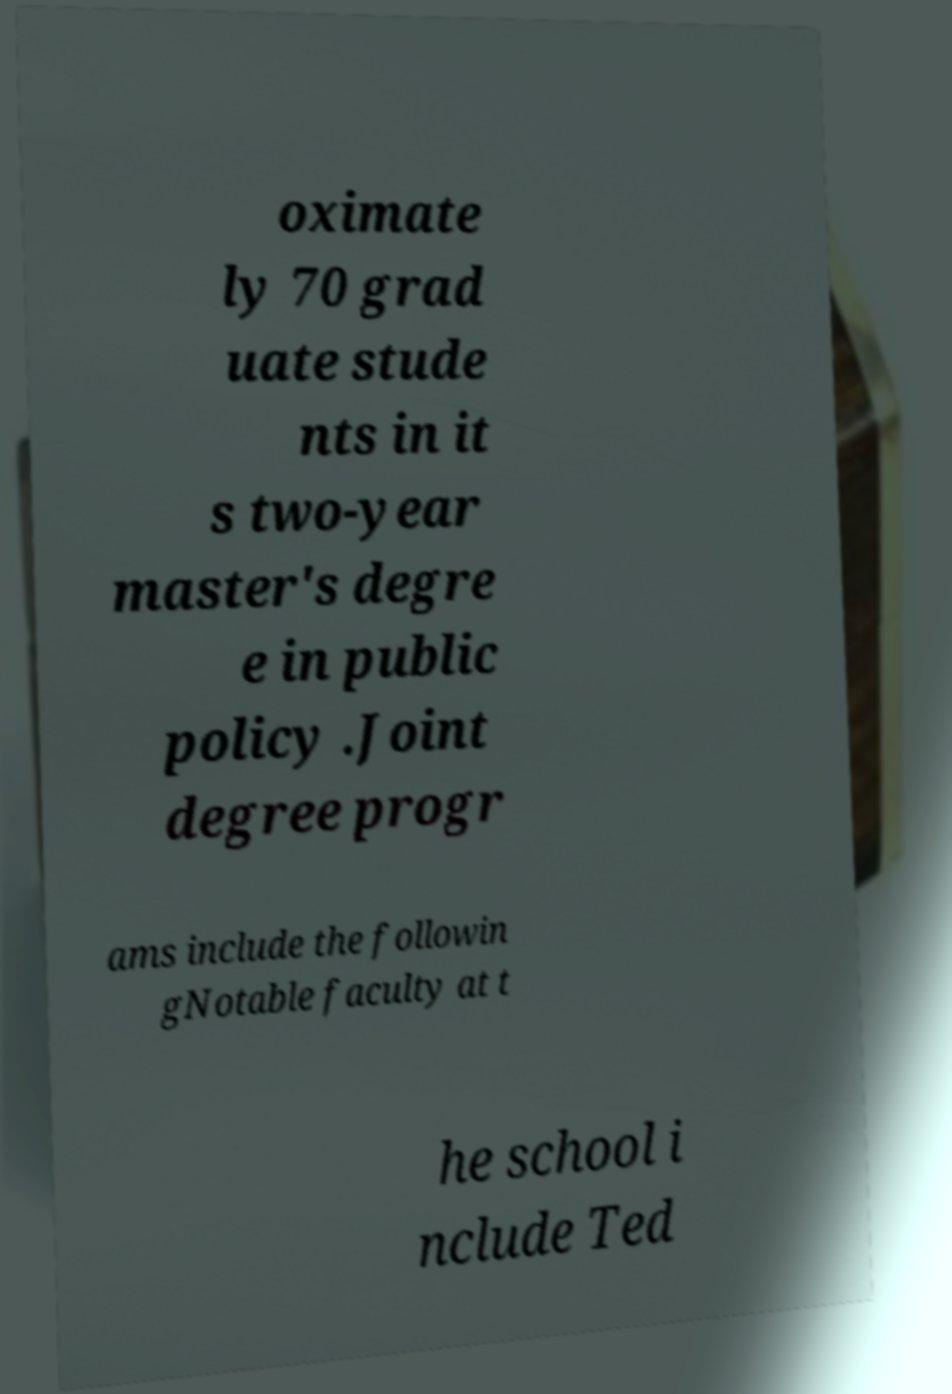Could you assist in decoding the text presented in this image and type it out clearly? oximate ly 70 grad uate stude nts in it s two-year master's degre e in public policy .Joint degree progr ams include the followin gNotable faculty at t he school i nclude Ted 